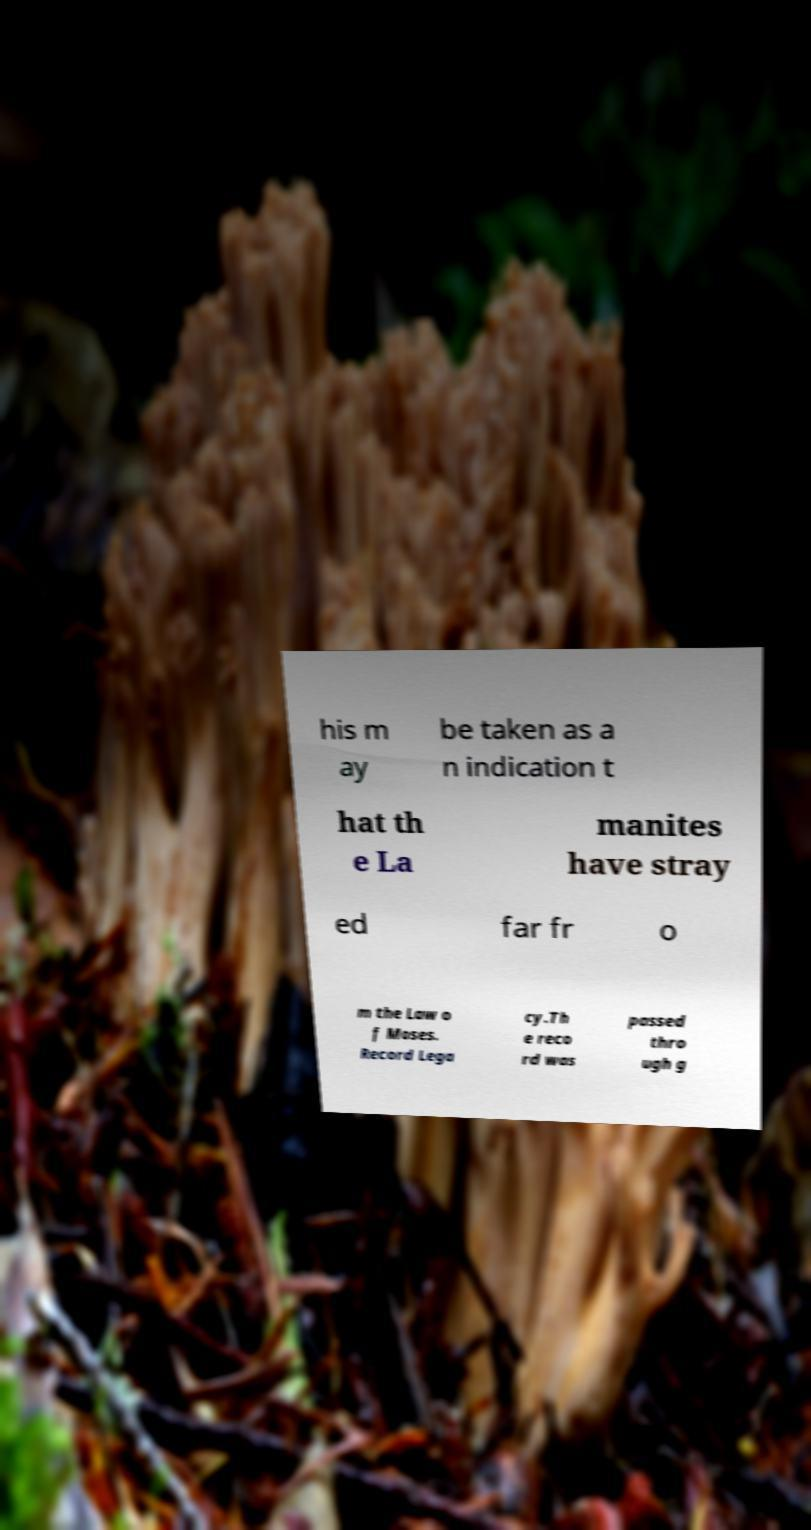Please identify and transcribe the text found in this image. his m ay be taken as a n indication t hat th e La manites have stray ed far fr o m the Law o f Moses. Record Lega cy.Th e reco rd was passed thro ugh g 